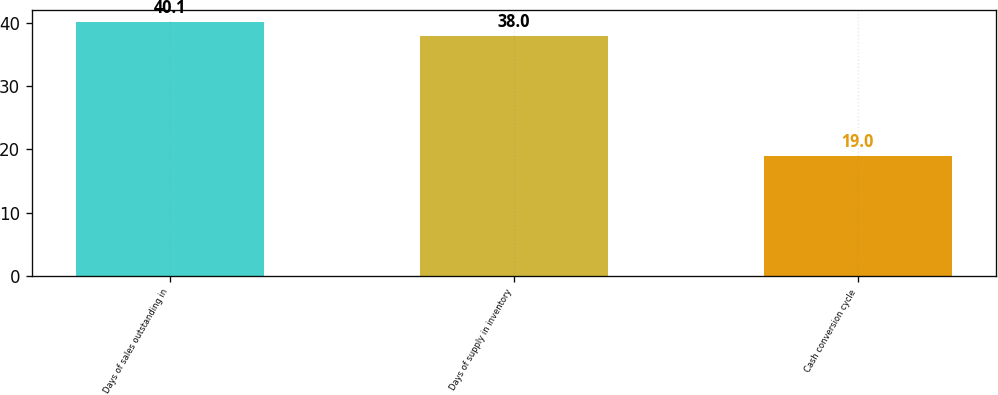<chart> <loc_0><loc_0><loc_500><loc_500><bar_chart><fcel>Days of sales outstanding in<fcel>Days of supply in inventory<fcel>Cash conversion cycle<nl><fcel>40.1<fcel>38<fcel>19<nl></chart> 